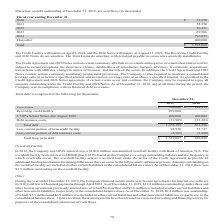According to Aci Worldwide's financial document, What were the term loans in 2019? According to the financial document, $756,060 (in thousands). The relevant text states: "Term loans $ 756,060 $ 284,959..." Also, What were the term loans in 2018? According to the financial document, $284,959 (in thousands). The relevant text states: "Term loans $ 756,060 $ 284,959..." Also, What was the Revolving credit facility in 2019? According to the financial document, 239,000 (in thousands). The relevant text states: "Revolving credit facility 239,000 —..." Also, can you calculate: What was the change in term loans between 2018 and 2019? Based on the calculation: $756,060-$284,959, the result is 471101 (in thousands). This is based on the information: "Term loans $ 756,060 $ 284,959 Term loans $ 756,060 $ 284,959..." The key data points involved are: 284,959, 756,060. Also, can you calculate: What was the change in total debt between 2018 and 2019? Based on the calculation: 1,373,155-671,756, the result is 701399 (in thousands). This is based on the information: "Total debt 1,373,155 671,756 Total debt 1,373,155 671,756..." The key data points involved are: 1,373,155, 671,756. Also, can you calculate: What was the percentage change in total long-term debt between 2018 and 2019? To answer this question, I need to perform calculations using the financial data. The calculation is: ($1,339,007-$650,989)/$650,989, which equals 105.69 (percentage). This is based on the information: "Total long-term debt $ 1,339,007 $ 650,989 Total long-term debt $ 1,339,007 $ 650,989..." The key data points involved are: 1,339,007, 650,989. 